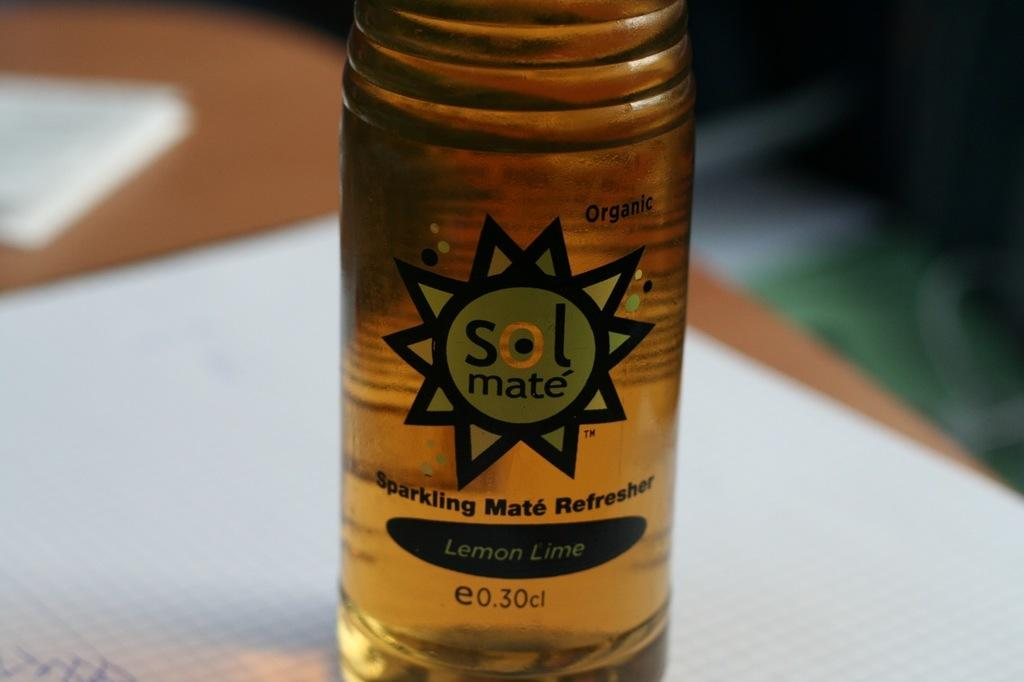<image>
Give a short and clear explanation of the subsequent image. A beverage, called sol mate, is lemon-lime flavor. 